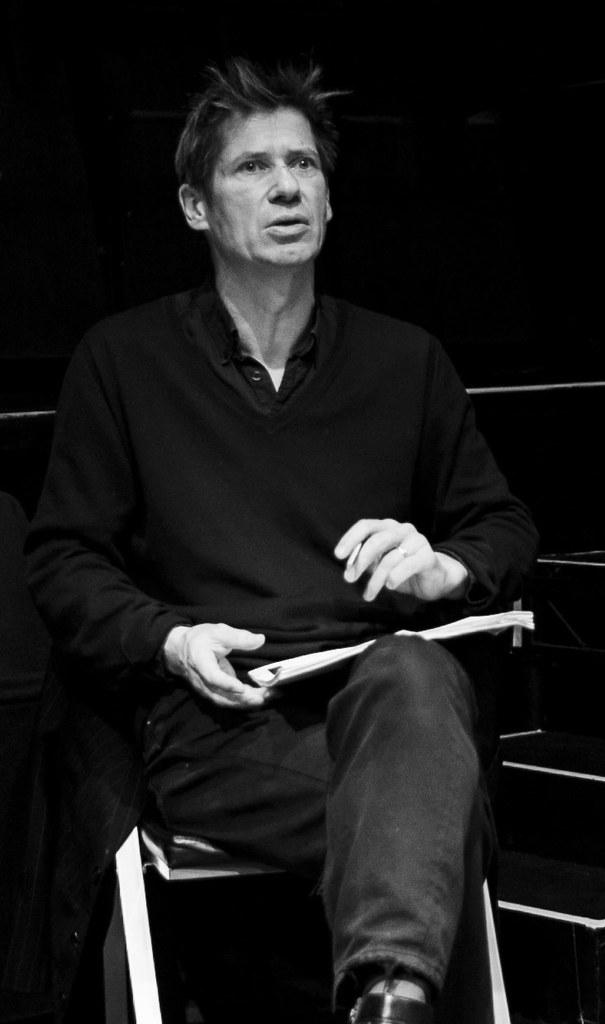What is the color scheme of the image? The image is black and white. Can you describe the person in the image? There is a man in the image. What is the man doing in the image? The man is sitting on a chair. What type of veil can be seen on the man's head in the image? There is no veil present on the man's head in the image, as it is a black and white image of a man sitting on a chair. 